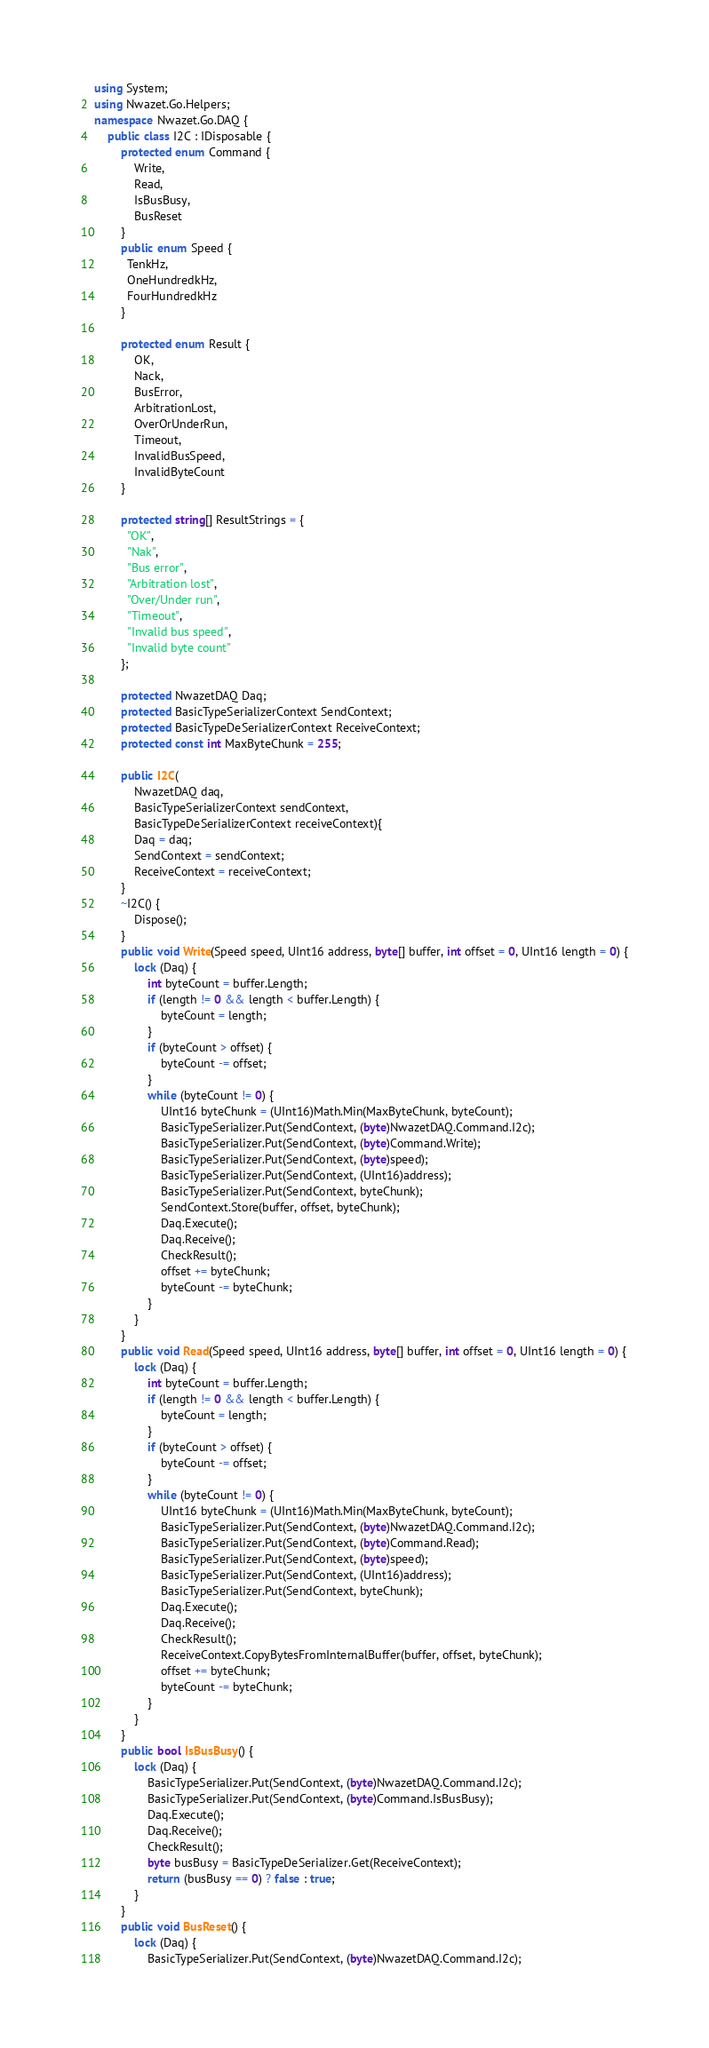Convert code to text. <code><loc_0><loc_0><loc_500><loc_500><_C#_>using System;
using Nwazet.Go.Helpers;
namespace Nwazet.Go.DAQ {
    public class I2C : IDisposable {
        protected enum Command {
            Write,
            Read,
            IsBusBusy,
            BusReset
        }
        public enum Speed {
          TenkHz,
          OneHundredkHz,
          FourHundredkHz
        }

        protected enum Result {
            OK,
            Nack,
            BusError,
            ArbitrationLost,
            OverOrUnderRun,
            Timeout,
            InvalidBusSpeed,
            InvalidByteCount
        }

        protected string[] ResultStrings = {
          "OK",
          "Nak",
          "Bus error",
          "Arbitration lost",
          "Over/Under run",
          "Timeout",
          "Invalid bus speed",
          "Invalid byte count"
        };

        protected NwazetDAQ Daq;
        protected BasicTypeSerializerContext SendContext;
        protected BasicTypeDeSerializerContext ReceiveContext;
        protected const int MaxByteChunk = 255;

        public I2C(
            NwazetDAQ daq,
            BasicTypeSerializerContext sendContext,
            BasicTypeDeSerializerContext receiveContext){
            Daq = daq;
            SendContext = sendContext;
            ReceiveContext = receiveContext;
        }
        ~I2C() {
            Dispose();
        }
        public void Write(Speed speed, UInt16 address, byte[] buffer, int offset = 0, UInt16 length = 0) {
            lock (Daq) {
                int byteCount = buffer.Length;
                if (length != 0 && length < buffer.Length) {
                    byteCount = length;
                }
                if (byteCount > offset) {
                    byteCount -= offset;
                }
                while (byteCount != 0) {
                    UInt16 byteChunk = (UInt16)Math.Min(MaxByteChunk, byteCount);
                    BasicTypeSerializer.Put(SendContext, (byte)NwazetDAQ.Command.I2c);
                    BasicTypeSerializer.Put(SendContext, (byte)Command.Write);
                    BasicTypeSerializer.Put(SendContext, (byte)speed);
                    BasicTypeSerializer.Put(SendContext, (UInt16)address);
                    BasicTypeSerializer.Put(SendContext, byteChunk);
                    SendContext.Store(buffer, offset, byteChunk);
                    Daq.Execute();
                    Daq.Receive();
                    CheckResult();
                    offset += byteChunk;
                    byteCount -= byteChunk;
                }
            }
        }
        public void Read(Speed speed, UInt16 address, byte[] buffer, int offset = 0, UInt16 length = 0) {
            lock (Daq) {
                int byteCount = buffer.Length;
                if (length != 0 && length < buffer.Length) {
                    byteCount = length;
                }
                if (byteCount > offset) {
                    byteCount -= offset;
                }
                while (byteCount != 0) {
                    UInt16 byteChunk = (UInt16)Math.Min(MaxByteChunk, byteCount);
                    BasicTypeSerializer.Put(SendContext, (byte)NwazetDAQ.Command.I2c);
                    BasicTypeSerializer.Put(SendContext, (byte)Command.Read);
                    BasicTypeSerializer.Put(SendContext, (byte)speed);
                    BasicTypeSerializer.Put(SendContext, (UInt16)address);
                    BasicTypeSerializer.Put(SendContext, byteChunk);
                    Daq.Execute();
                    Daq.Receive();
                    CheckResult();
                    ReceiveContext.CopyBytesFromInternalBuffer(buffer, offset, byteChunk);
                    offset += byteChunk;
                    byteCount -= byteChunk;
                }
            }
        }
        public bool IsBusBusy() {
            lock (Daq) {
                BasicTypeSerializer.Put(SendContext, (byte)NwazetDAQ.Command.I2c);
                BasicTypeSerializer.Put(SendContext, (byte)Command.IsBusBusy);
                Daq.Execute();
                Daq.Receive();
                CheckResult();
                byte busBusy = BasicTypeDeSerializer.Get(ReceiveContext);
                return (busBusy == 0) ? false : true;
            }
        }
        public void BusReset() {
            lock (Daq) {
                BasicTypeSerializer.Put(SendContext, (byte)NwazetDAQ.Command.I2c);</code> 